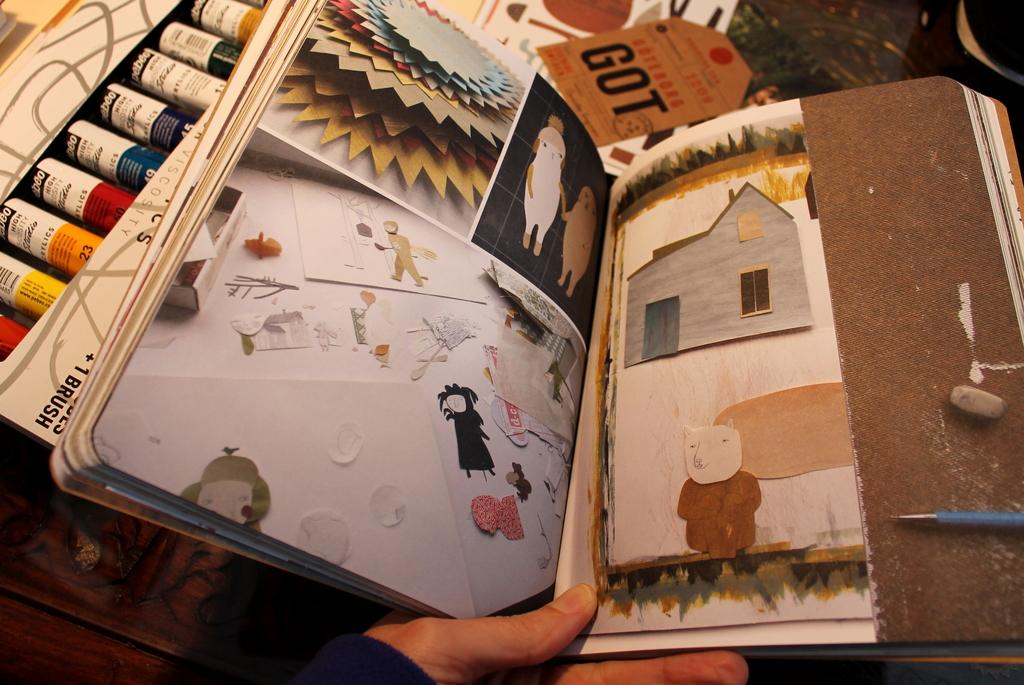<image>
Give a short and clear explanation of the subsequent image. A scrapbook is decorated with a hodgepodge of images, including a tag with GOT on it. 